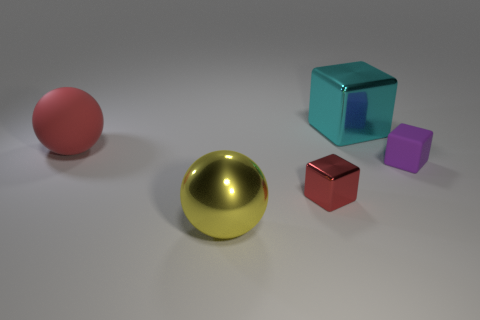There is a tiny thing that is the same color as the rubber ball; what is it made of?
Offer a terse response. Metal. How many other objects are the same size as the purple object?
Give a very brief answer. 1. Do the cyan block and the yellow sphere have the same size?
Offer a very short reply. Yes. Are there any small rubber spheres?
Your answer should be very brief. No. Are there any small purple cubes made of the same material as the large yellow sphere?
Give a very brief answer. No. There is a cyan cube that is the same size as the red ball; what is it made of?
Offer a very short reply. Metal. How many red rubber things are the same shape as the yellow shiny thing?
Make the answer very short. 1. What size is the yellow ball that is made of the same material as the cyan object?
Keep it short and to the point. Large. There is a big object that is in front of the large cyan shiny thing and behind the small matte object; what is its material?
Ensure brevity in your answer.  Rubber. How many metallic things are the same size as the matte sphere?
Make the answer very short. 2. 